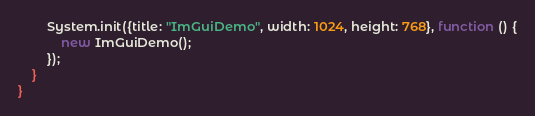Convert code to text. <code><loc_0><loc_0><loc_500><loc_500><_Haxe_>		System.init({title: "ImGuiDemo", width: 1024, height: 768}, function () {
			new ImGuiDemo();
		});
	}
}
</code> 